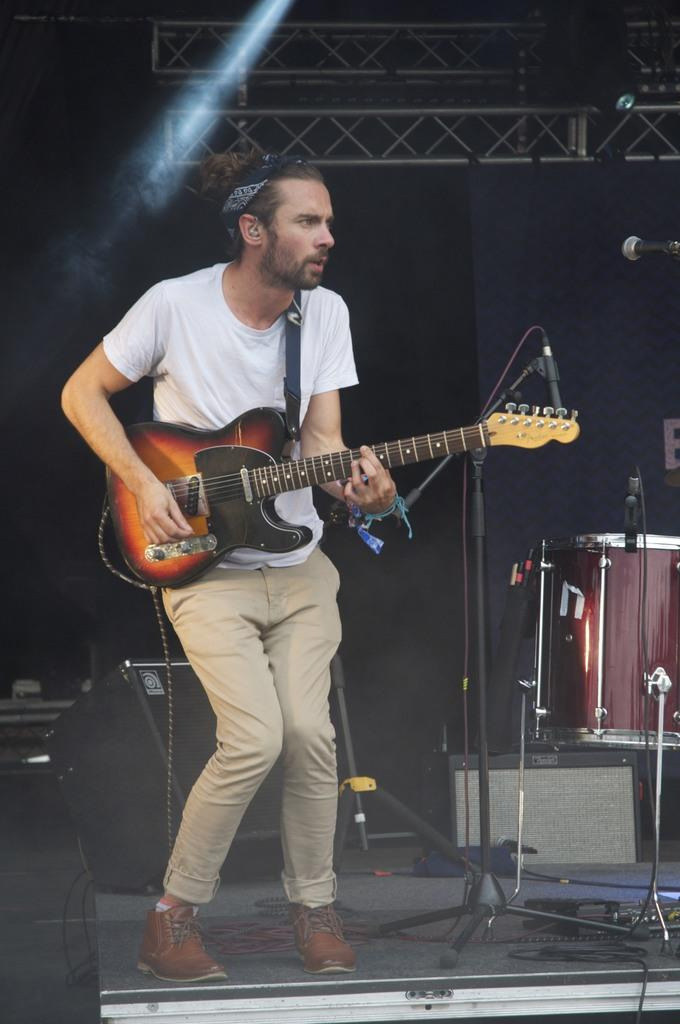What is the man in the image doing? The man is playing a guitar in the image. What is the man wearing? The man is wearing a white t-shirt in the image. What objects can be seen on the stage? There is a mic with a stand, a musical drum, and a speaker on the stage. What musical note is the man playing on the guitar in the image? The image does not provide information about the specific musical note being played by the man on the guitar. Is the stage located in a cellar in the image? There is no information about the location of the stage in the image, so it cannot be determined if it is in a cellar or not. 